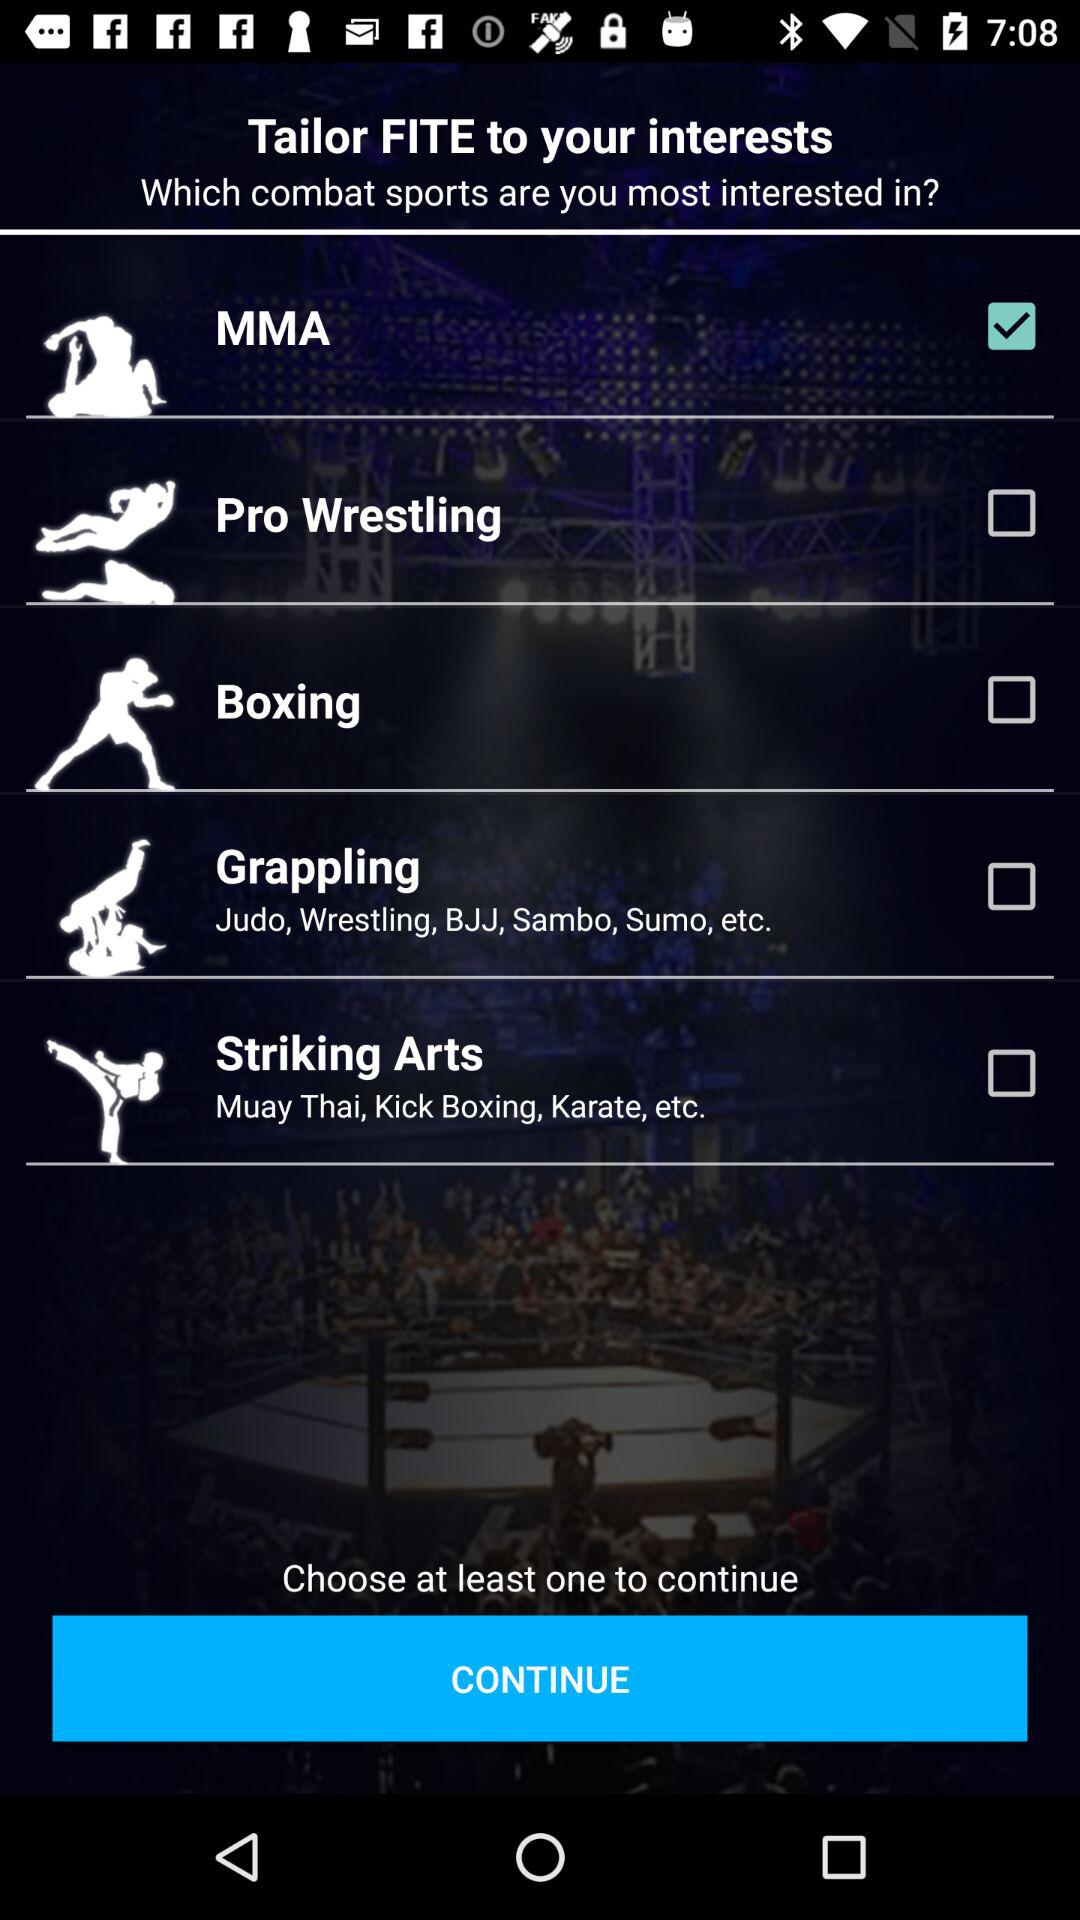What does MMA stand for?
When the provided information is insufficient, respond with <no answer>. <no answer> 